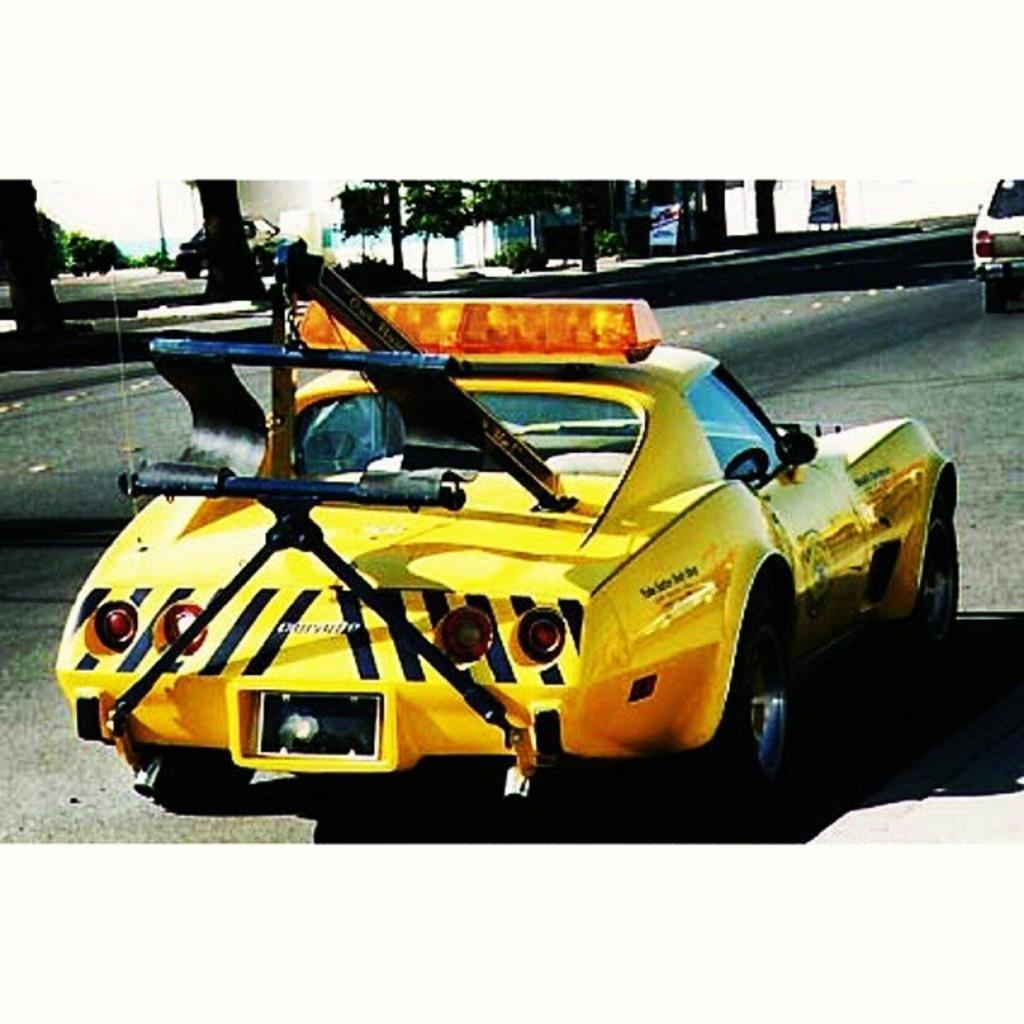Can you describe this image briefly? In this image there is a yellow color car and a white color car on the road, and at the background there are trees, plants, hoardings, sky. 